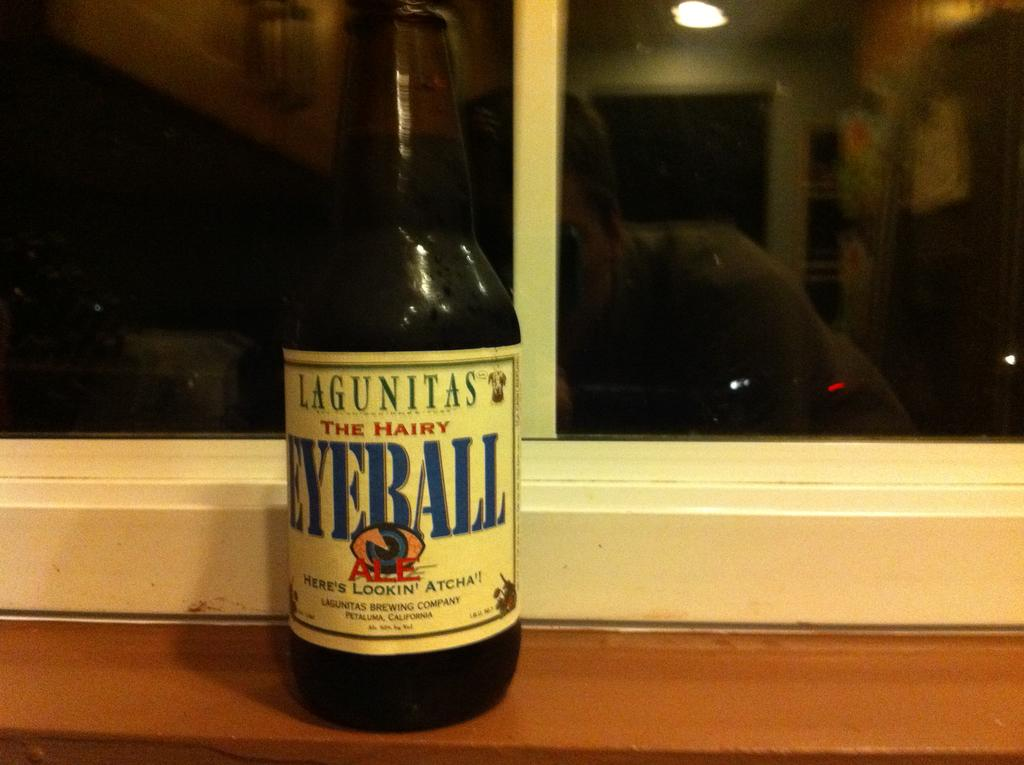<image>
Present a compact description of the photo's key features. A bottle of Lagunitas Eyeball on a window sill 